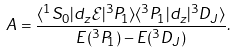Convert formula to latex. <formula><loc_0><loc_0><loc_500><loc_500>A = \frac { \langle ^ { 1 } S _ { 0 } | d _ { z } { \mathcal { E } } | ^ { 3 } P _ { 1 } \rangle \langle ^ { 3 } P _ { 1 } | d _ { z } | ^ { 3 } D _ { J } \rangle } { E ( ^ { 3 } P _ { 1 } ) - E ( ^ { 3 } D _ { J } ) } .</formula> 